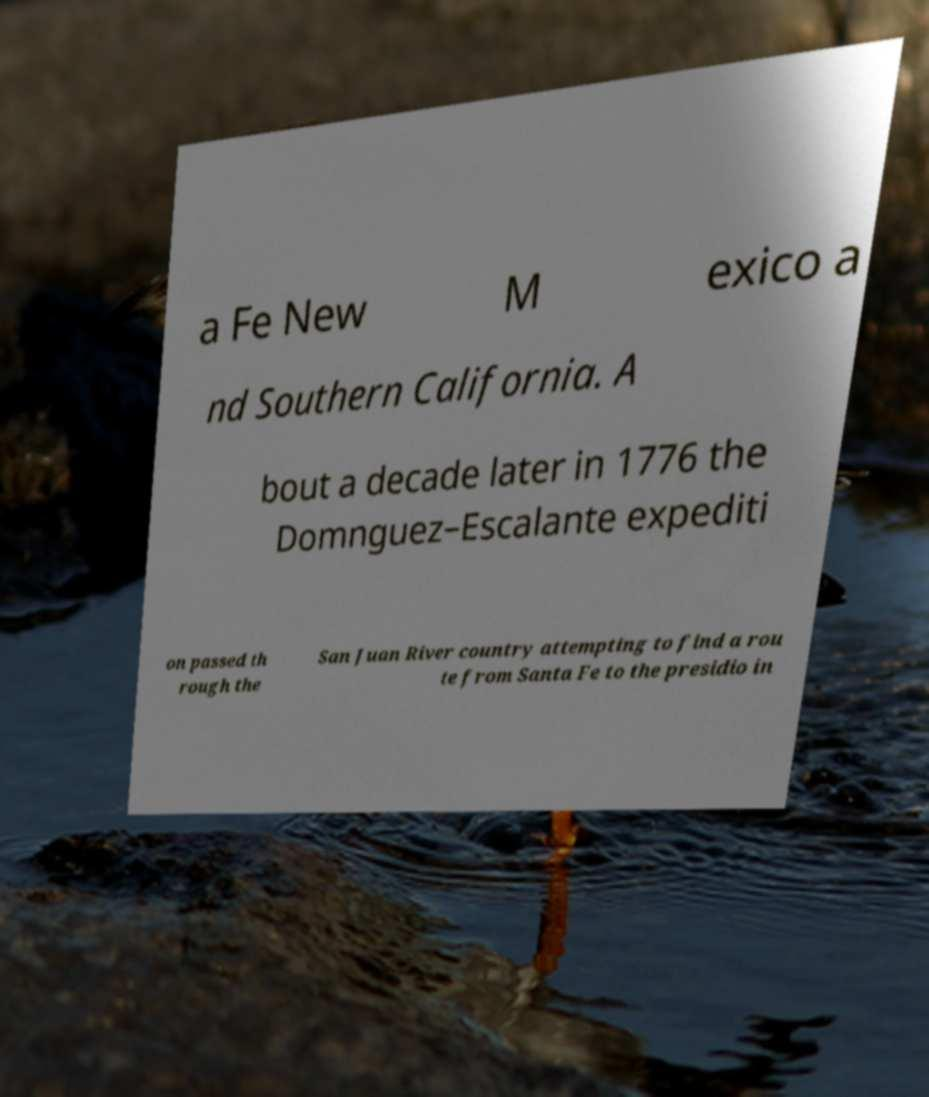Please read and relay the text visible in this image. What does it say? a Fe New M exico a nd Southern California. A bout a decade later in 1776 the Domnguez–Escalante expediti on passed th rough the San Juan River country attempting to find a rou te from Santa Fe to the presidio in 